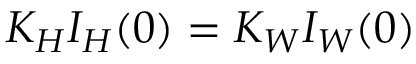Convert formula to latex. <formula><loc_0><loc_0><loc_500><loc_500>K _ { H } I _ { H } ( 0 ) = K _ { W } I _ { W } ( 0 )</formula> 